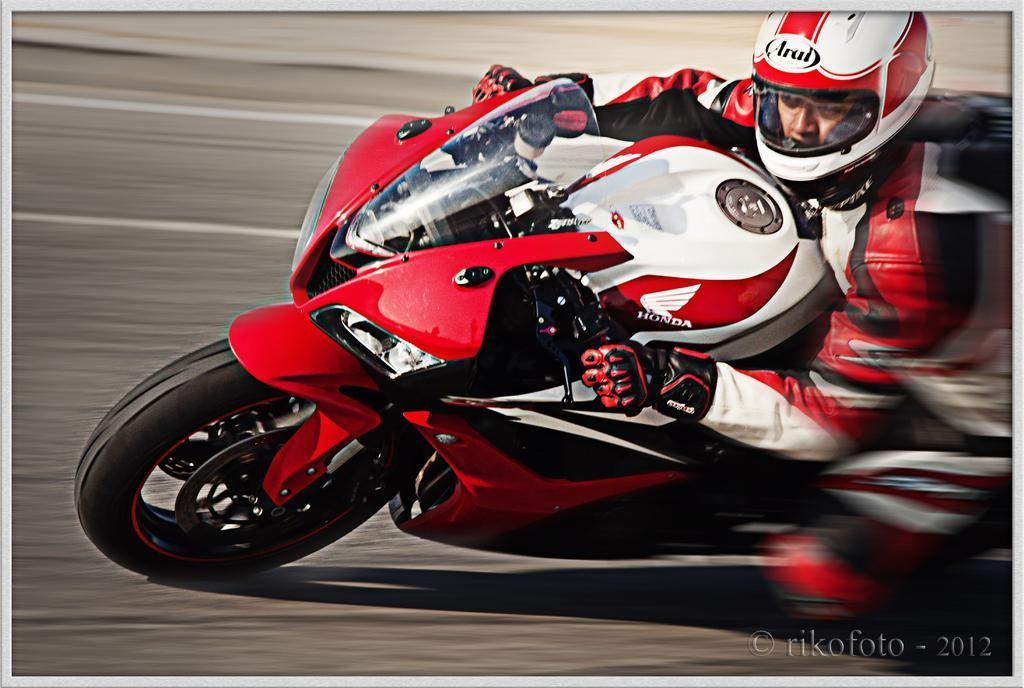Could you give a brief overview of what you see in this image? In this image, in the middle, we can see a man riding a bike which is in red color. In the background, we can see a road. 